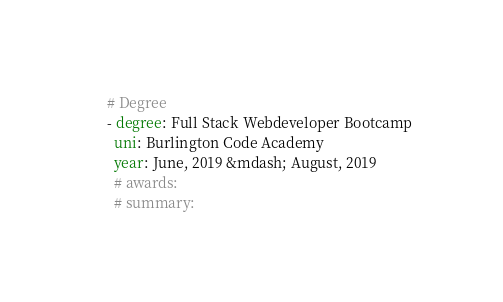<code> <loc_0><loc_0><loc_500><loc_500><_YAML_># Degree
- degree: Full Stack Webdeveloper Bootcamp
  uni: Burlington Code Academy
  year: June, 2019 &mdash; August, 2019
  # awards:
  # summary:
</code> 